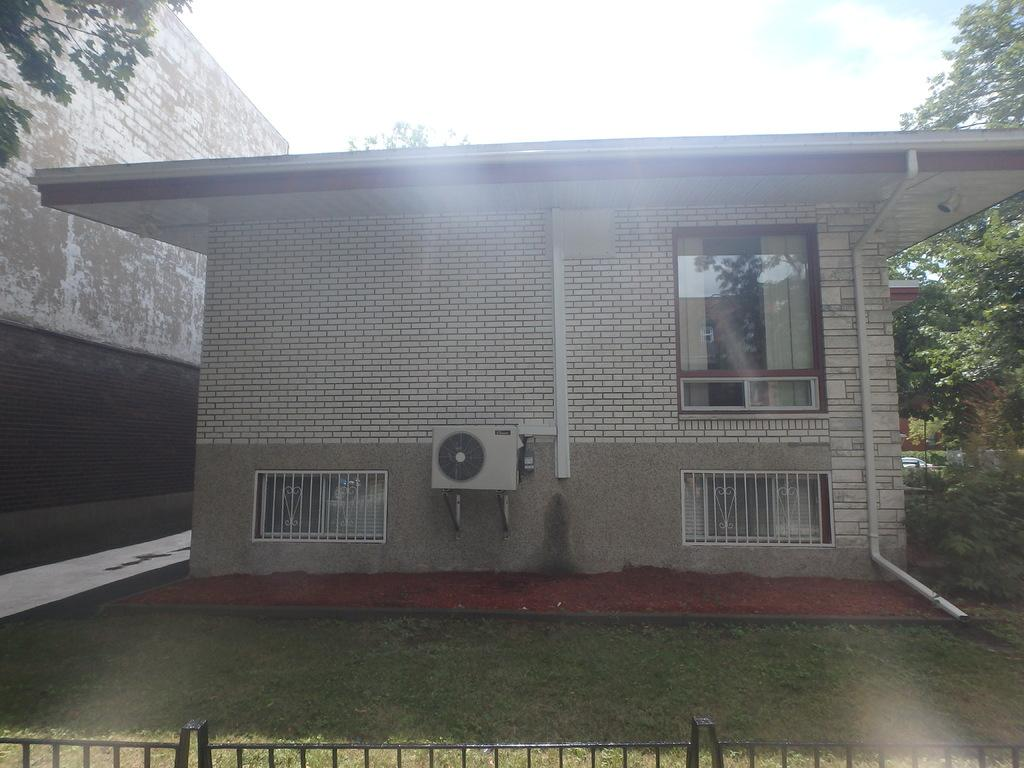What type of structures can be seen in the image? There are buildings in the image. What appliances are visible on the buildings? There are air conditioners in the image. What cooking equipment can be seen in the image? There are grills in the image. What part of the natural environment is visible in the image? The ground and trees are visible in the image. What part of the sky is visible in the image? The sky is visible in the image. What note is the building playing in the image? There is no note being played by the building in the image, as buildings do not have the ability to play music. 